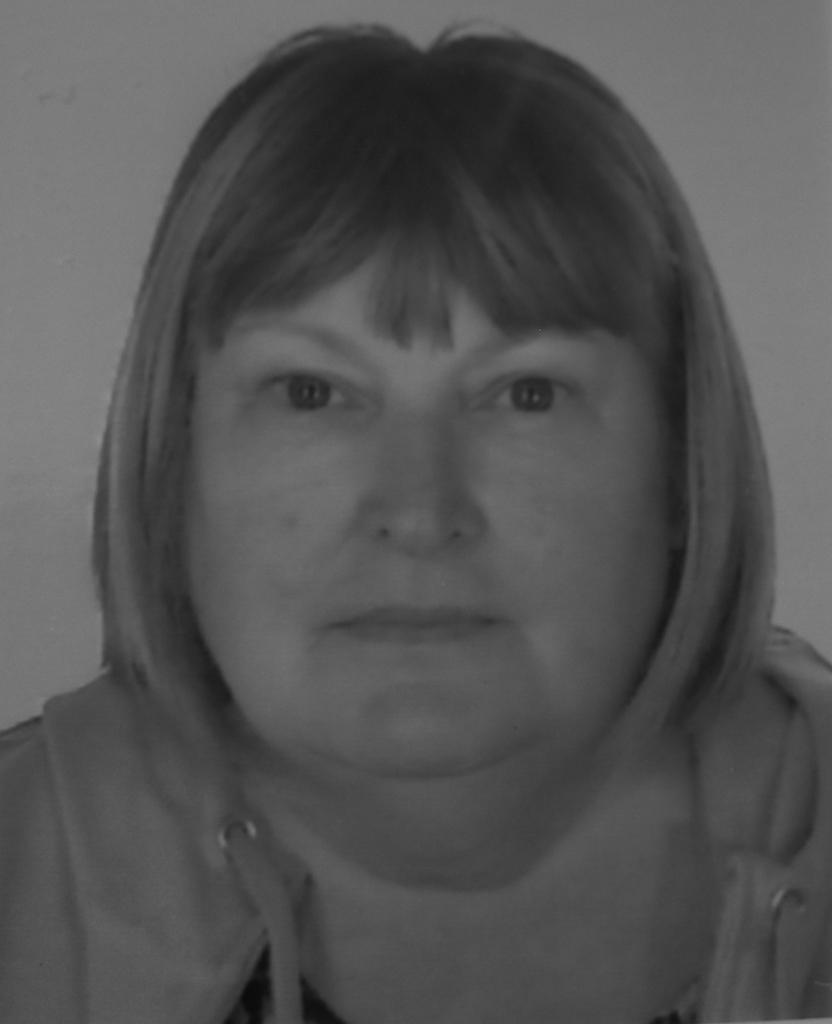What is the main subject of the image? There is a woman in the image. Where is the woman located in the image? The woman is in the center of the image. What type of thread is being used by the woman in the image? There is no thread present in the image, as the woman is the only subject. What relation does the woman have with the wilderness in the image? There is no wilderness present in the image, so it is not possible to determine any relation between the woman and the wilderness. 